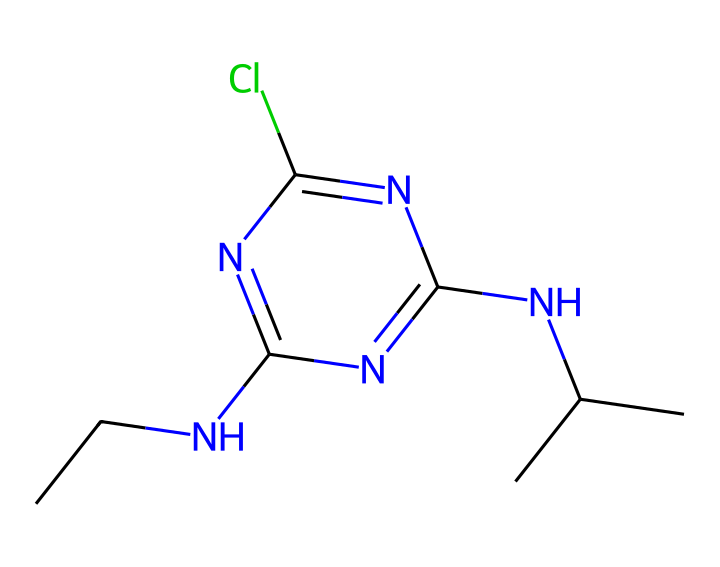What is the molecular formula of atrazine? To find the molecular formula, we count the number of each type of atom in the SMILES representation. Here, we see there are 9 carbon (C), 14 hydrogen (H), 2 nitrogen (N), 1 chlorine (Cl), and 1 constituent of phosphorus not shown in the basic structure. Thus, the molecular formula is C8H14ClN5.
Answer: C8H14ClN5 How many nitrogen atoms are present in atrazine? By analyzing the SMILES, we can see there are five nitrogen (N) atoms shown in the structure as represented by 'N' and 'n'. Therefore, the answer is five.
Answer: five What type of herbicide is atrazine classified as? Atrazine is classified as a triazine herbicide due to the presence of a triazine ring in its structure, which is characteristic of this class of herbicides used in agriculture.
Answer: triazine Which functional groups are present in atrazine? By scrutinizing the SMILES, we identify a primary amine group (−NH2) and a chlorinated component (−Cl) as part of the structure, indicating it possesses these functional groups.
Answer: amine, chlorinated Does atrazine have potential environmental impacts? Yes, atrazine has been known to contaminate groundwater and water sources due to agricultural runoff, thus posing potential environmental and health impacts.
Answer: Yes 